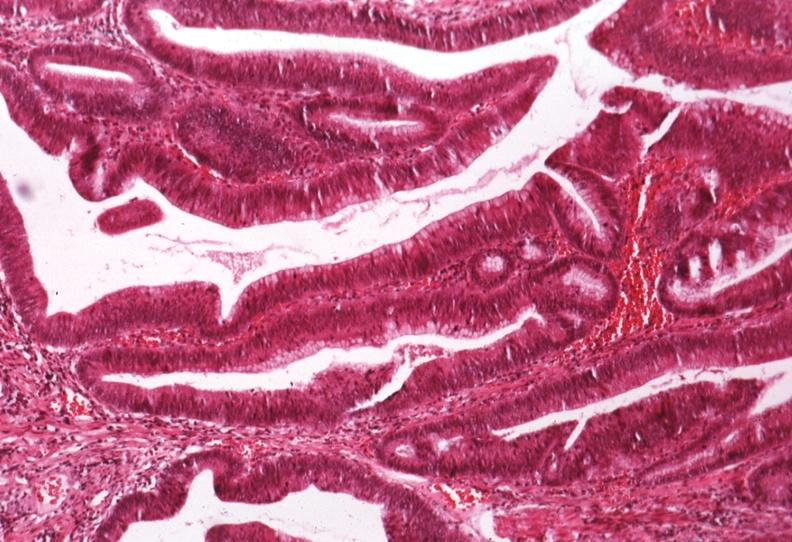what is present?
Answer the question using a single word or phrase. Villous adenoma 